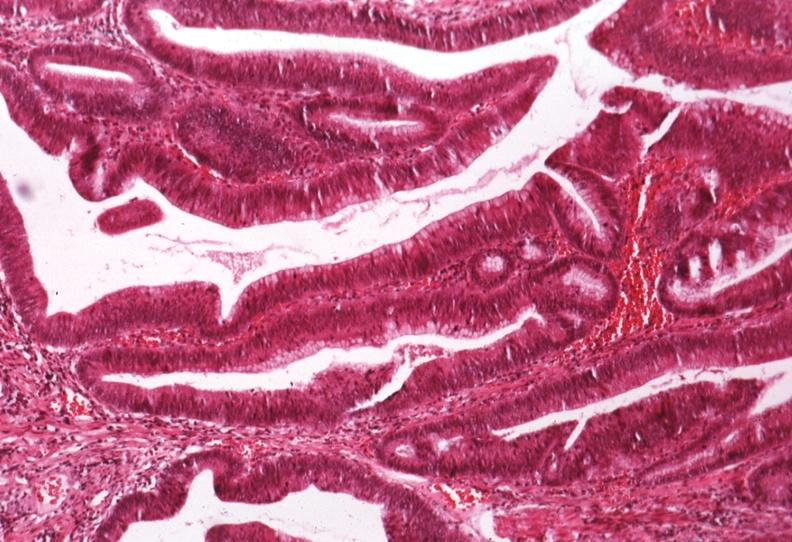what is present?
Answer the question using a single word or phrase. Villous adenoma 